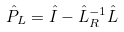Convert formula to latex. <formula><loc_0><loc_0><loc_500><loc_500>\hat { P } _ { L } = \hat { I } - \hat { L } _ { R } ^ { - 1 } \hat { L }</formula> 